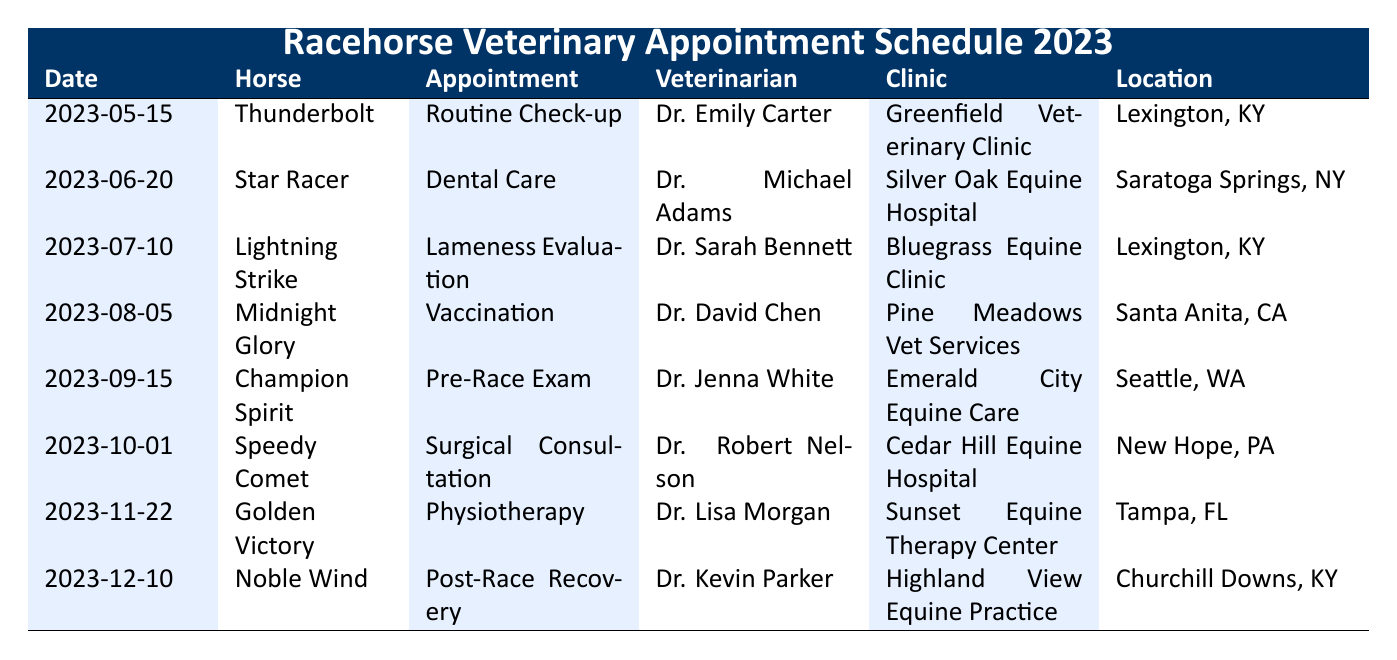What type of appointment did Thunderbolt have? Thunderbolt's appointment on May 15, 2023, was a Routine Check-up as indicated in the table.
Answer: Routine Check-up Who was the veterinarian for Lightning Strike? The veterinarian for Lightning Strike's lameness evaluation on July 10, 2023, is Dr. Sarah Bennett, as shown in the table.
Answer: Dr. Sarah Bennett How many horses had appointments in Lexington, KY? The table lists three appointments in Lexington, KY: Thunderbolt for a Routine Check-up, Lightning Strike for a Lameness Evaluation, and there are no others, confirming a total of 2 appointments.
Answer: 2 Did Golden Victory receive a vaccination? According to the table, Golden Victory had a Physiotherapy appointment on November 22, 2023, and did not receive a vaccination. Therefore, the answer is no.
Answer: No Which horse had a pre-race exam and what was the date? The horse that had a pre-race exam was Champion Spirit, and the date of the appointment was September 15, 2023, as indicated in the table.
Answer: Champion Spirit on September 15, 2023 What was the common appointment type among the last two horses in the schedule? The last two horses, Golden Victory and Noble Wind, had appointments for Physiotherapy and Post-Race Recovery, respectively, where neither had the same appointment type. Hence, there is no common appointment type.
Answer: No common appointment type How many different veterinarians were involved in these appointments? Upon reviewing the table, there are a total of 8 different veterinarians: Dr. Emily Carter, Dr. Michael Adams, Dr. Sarah Bennett, Dr. David Chen, Dr. Jenna White, Dr. Robert Nelson, Dr. Lisa Morgan, and Dr. Kevin Parker. This sums up to 8 distinct veterinarians.
Answer: 8 What is the appointment type for Speedy Comet and who was the vet? Speedy Comet had a Surgical Consultation appointment on October 1, 2023, with veterinarian Dr. Robert Nelson, as captured in the table.
Answer: Surgical Consultation by Dr. Robert Nelson 